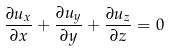Convert formula to latex. <formula><loc_0><loc_0><loc_500><loc_500>\frac { \partial u _ { x } } { \partial x } + \frac { \partial u _ { y } } { \partial y } + \frac { \partial u _ { z } } { \partial z } = 0</formula> 